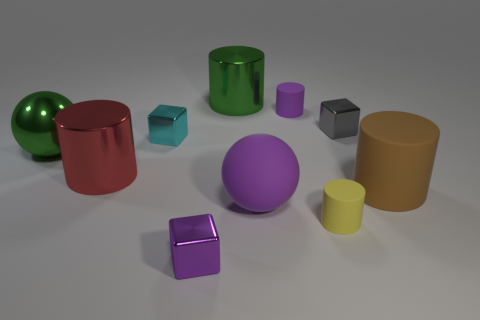What is the size of the purple thing that is made of the same material as the tiny gray thing?
Your answer should be very brief. Small. Is the color of the rubber sphere the same as the metal ball?
Keep it short and to the point. No. There is a rubber thing behind the large green metallic sphere; is its shape the same as the small yellow thing?
Your answer should be compact. Yes. What number of cyan things are the same size as the purple sphere?
Provide a succinct answer. 0. There is a object that is the same color as the large shiny ball; what is its shape?
Provide a succinct answer. Cylinder. There is a purple thing that is behind the gray shiny cube; are there any cyan things that are on the right side of it?
Provide a short and direct response. No. How many objects are either small objects that are to the left of the big green cylinder or small gray balls?
Give a very brief answer. 2. How many cylinders are there?
Your answer should be compact. 5. There is a tiny purple object that is made of the same material as the red cylinder; what is its shape?
Give a very brief answer. Cube. What is the size of the green metal object left of the green object right of the tiny purple metallic cube?
Make the answer very short. Large. 